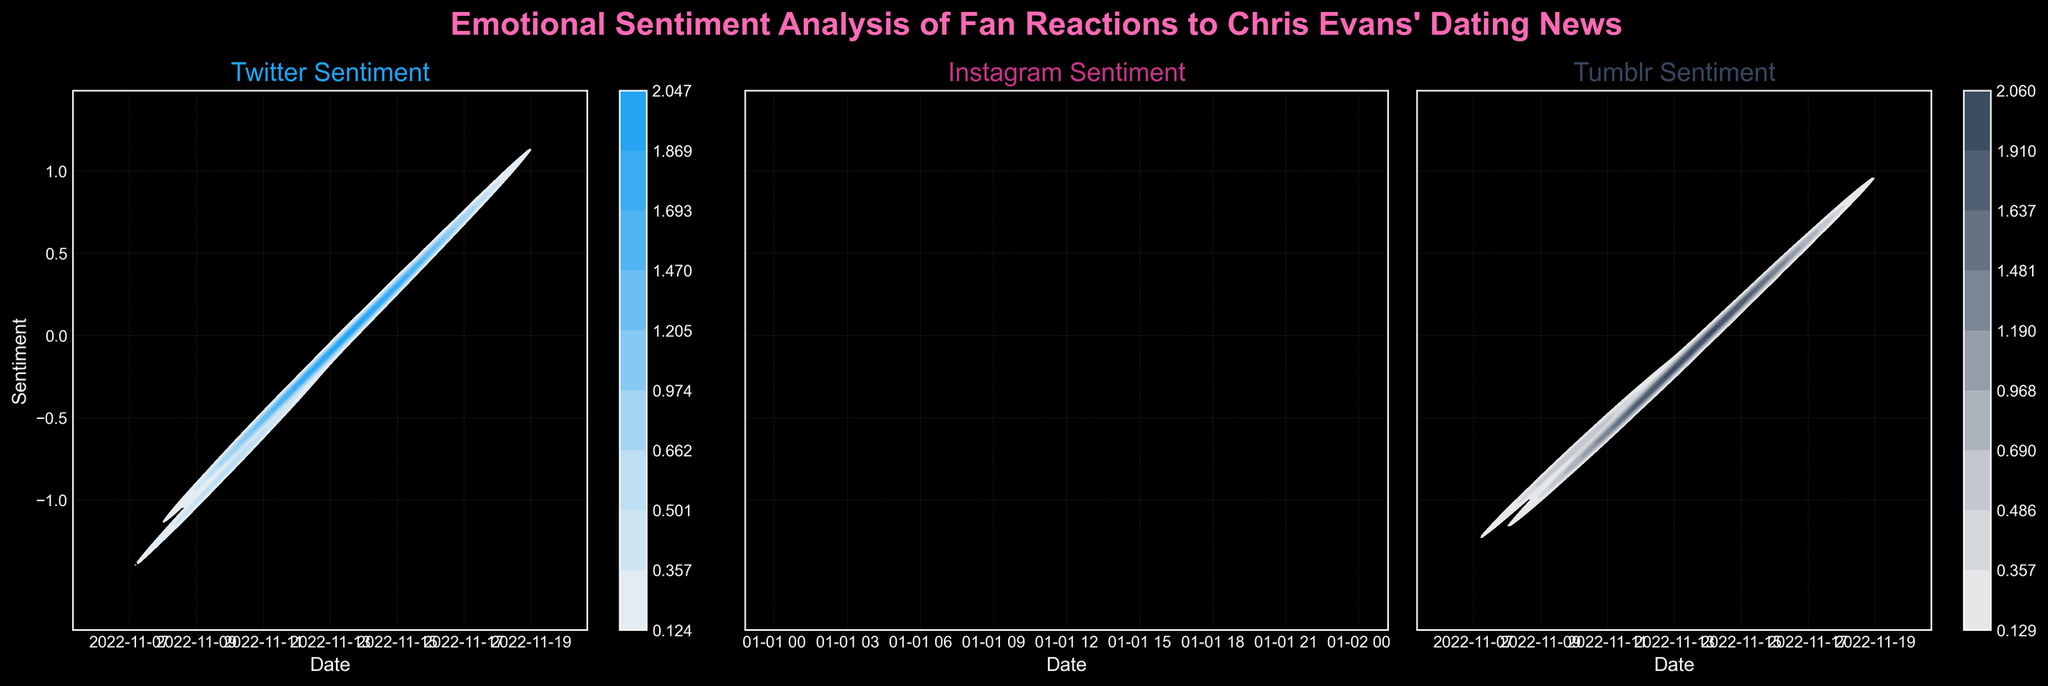What is the title of the figure? The title is usually found on top of the figure, and it describes what the diagram is about. In this case, it is "Emotional Sentiment Analysis of Fan Reactions to Chris Evans' Dating News."
Answer: Emotional Sentiment Analysis of Fan Reactions to Chris Evans' Dating News What platforms are compared in the density plots? The subtitle of each subplot specifies the platform being analyzed. In this case, there are three subplots for Twitter, Instagram, and Tumblr.
Answer: Twitter, Instagram, Tumblr What is the color theme for the Twitter sentiment plot? The hue color used in each subplot differentiates the platforms. Twitter usually uses blue, which is also indicated here.
Answer: Blue How do sentiments trend over time on Instagram? By observing the color intensity and density distribution from the left to the right on the Instagram subplot, you can see that sentiments move from negative values towards positive values over time.
Answer: Positive trend over time Which platform shows the highest peak in sentiment density? By comparing the density (color intensity) across the three platforms' subplots, we see that Instagram shows the highest peak in sentiment density around the later dates.
Answer: Instagram Are there any platforms where sentiment closely reaches a neutral (0) value? By examining how close the sentiment values come to zero on the y-axis of each subplot, Instagram sentiment reaches near the neutral value of 0 around mid-dates.
Answer: Instagram Which platform shows the most negative sentiment initially? Early dates are on the left side of the subplots. By comparing the darker density on the left, Twitter has the lowest negative sentiment initially.
Answer: Twitter Did Tumblr sentiments ever reach as positive as other platforms? By comparing the highest sentiment values on the right side of all platforms' plots, Tumblr sentiments are lower compared to Twitter and Instagram towards the end dates.
Answer: No What are the axes labels in the subplots? Each subplot has its axis labels visible at the sides. The x-axis represents 'Date,' and the y-axis represents 'Sentiment' in each subplot.
Answer: Date, Sentiment Between which dates did fan sentiments show the most rapid change? By analyzing the steepness of color gradient transitions (representing density changes) across the x-axis (dates) within each subplot, sentiments change rapidly between November 10 and November 13.
Answer: November 10 - November 13 